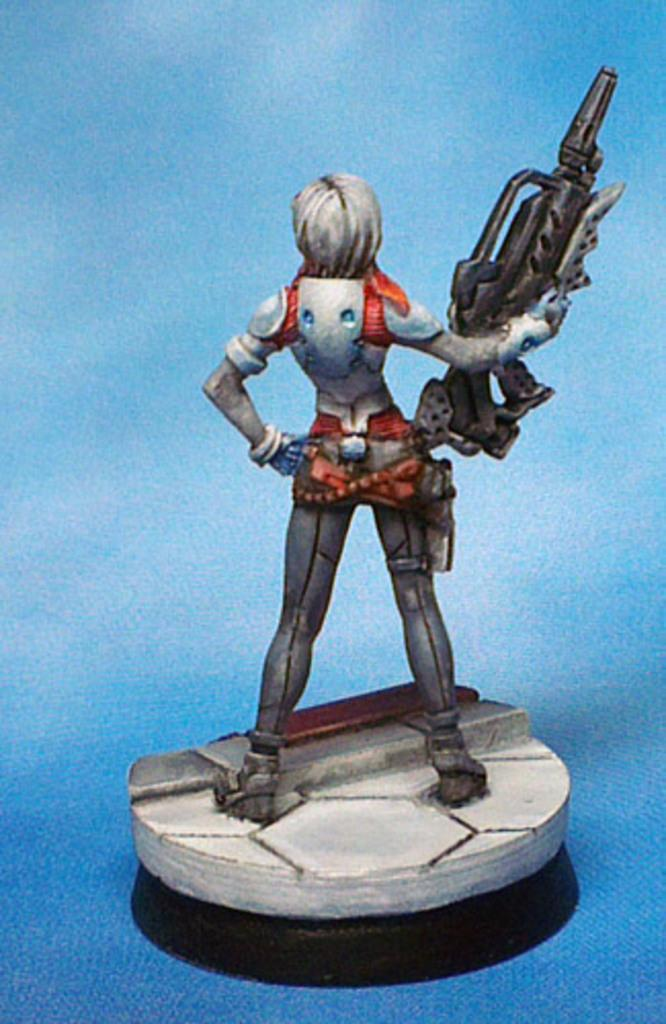What type of image is being described? The image is animated. Can you describe the character in the image? There is a person in the image. What is the person doing in the image? The person is standing. What object is the person holding in the image? The person is holding a gun. What type of wine is being served at the school in the image? There is no school or wine present in the image; it features an animated person standing and holding a gun. 